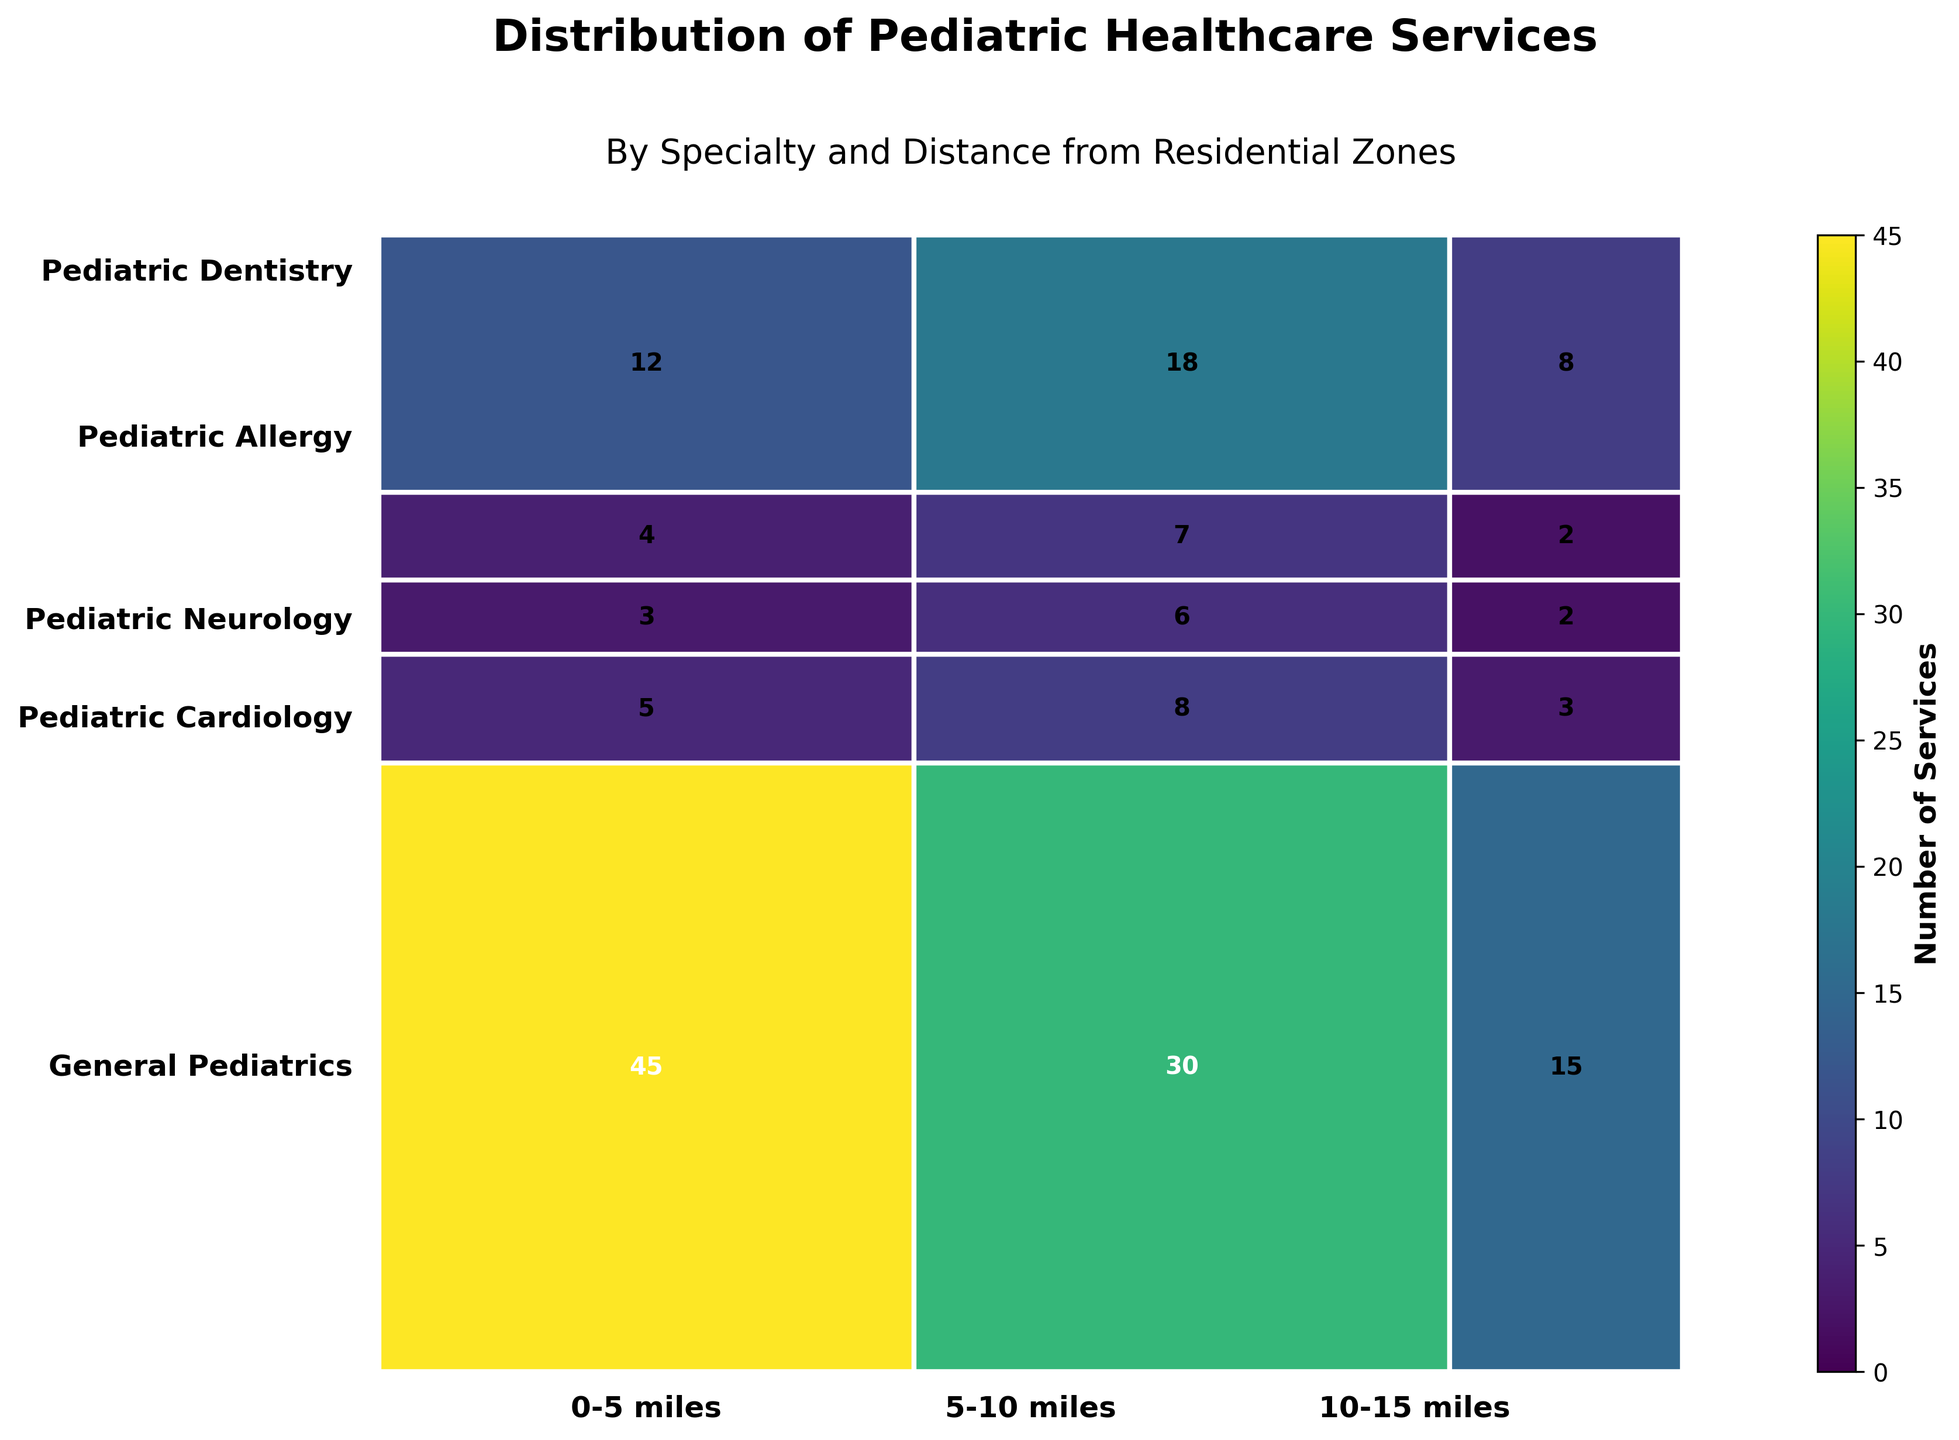What's the most common pediatric specialty within 0-5 miles? We look at the largest rectangle within the 0-5 miles section. The largest rectangle corresponds to General Pediatrics with a count of 45.
Answer: General Pediatrics How many pediatric dentistry services are within 5-10 miles? We find the rectangle corresponding to Pediatric Dentistry within the 5-10 miles section. The count labeled there is 18.
Answer: 18 Which specialty within 10-15 miles has the fewest services? We examine the smallest rectangle within the 10-15 miles section. The specialty with the smallest rectangle is Pediatric Neurology with a count of 2.
Answer: Pediatric Neurology Compare the number of Pediatric Cardiology services 0-5 miles and 5-10 miles from residential zones. Which is higher? We compare the rectangles of Pediatric Cardiology within 0-5 miles (5 services) and 5-10 miles (8 services). The count is higher within the 5-10 miles zone.
Answer: 5-10 miles What's the total number of General Pediatrics services across all distances? We sum the counts for General Pediatrics across all distances: 45 (0-5 miles) + 30 (5-10 miles) + 15 (10-15 miles) = 90.
Answer: 90 How does the number of General Pediatrics services 0-5 miles compare to Pediatric Dentistry services in the same distance? We look at the counts for General Pediatrics (45 services) and Pediatric Dentistry (12 services) within 0-5 miles. General Pediatrics has a significantly higher count.
Answer: General Pediatrics Which distance range has the most pediatric services overall? We sum the counts for all specialties within each distance range: 
0-5 miles: 45 + 5 + 3 + 4 + 12 = 69,
5-10 miles: 30 + 8 + 6 + 7 + 18 = 69,
10-15 miles: 15 + 3 + 2 + 2 + 8 = 30.
Both 0-5 and 5-10 miles have the most, each with 69 services.
Answer: 0-5 miles, 5-10 miles Compare the sum of Pediatric Neurology services within 0-5 miles and Pediatric Allergy services within 10-15 miles. Which one is higher and by how much? Pediatric Neurology (0-5 miles): 3 services. Pediatric Allergy (10-15 miles): 2 services. Pediatric Neurology has 1 more service.
Answer: Pediatric Neurology by 1 What is the total number of pediatric healthcare services provided within the 10-15 miles zone? We sum the counts for all specialties within the 10-15 miles range: 15 (General Pediatrics) + 3 (Pediatric Cardiology) + 2 (Pediatric Neurology) + 2 (Pediatric Allergy) + 8 (Pediatric Dentistry) = 30.
Answer: 30 